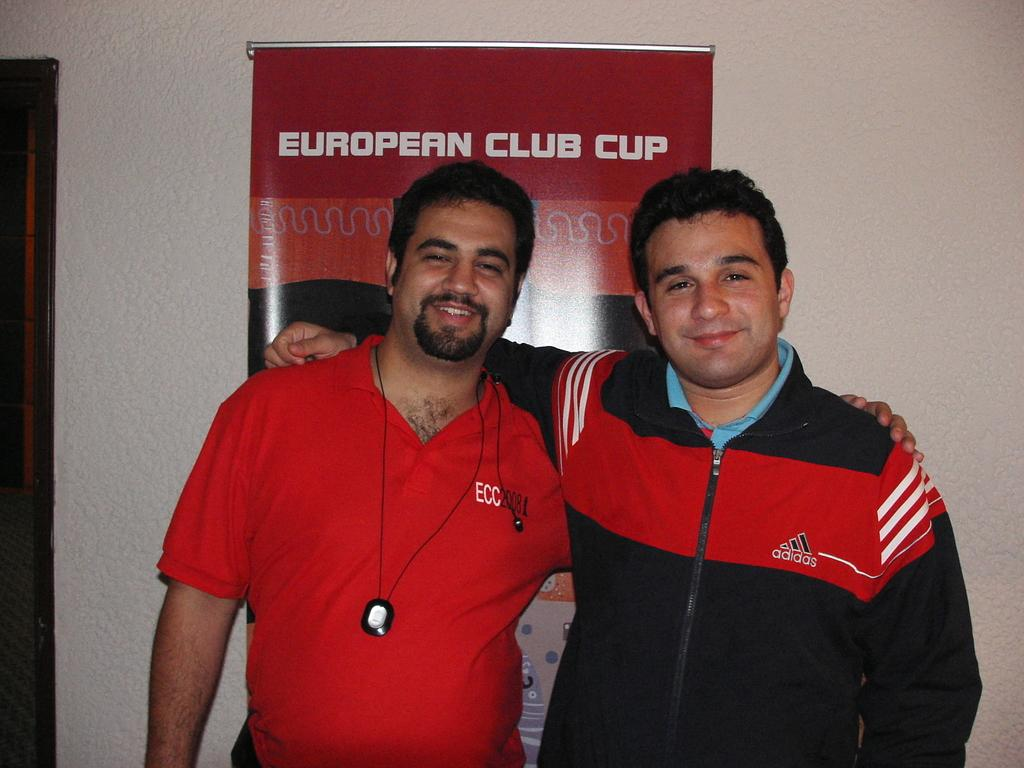<image>
Relay a brief, clear account of the picture shown. Two men pose in front of a poster for the European Club Cup. 